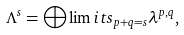Convert formula to latex. <formula><loc_0><loc_0><loc_500><loc_500>\Lambda ^ { s } = \bigoplus \lim i t s _ { p + q = s } \lambda ^ { p , q } ,</formula> 